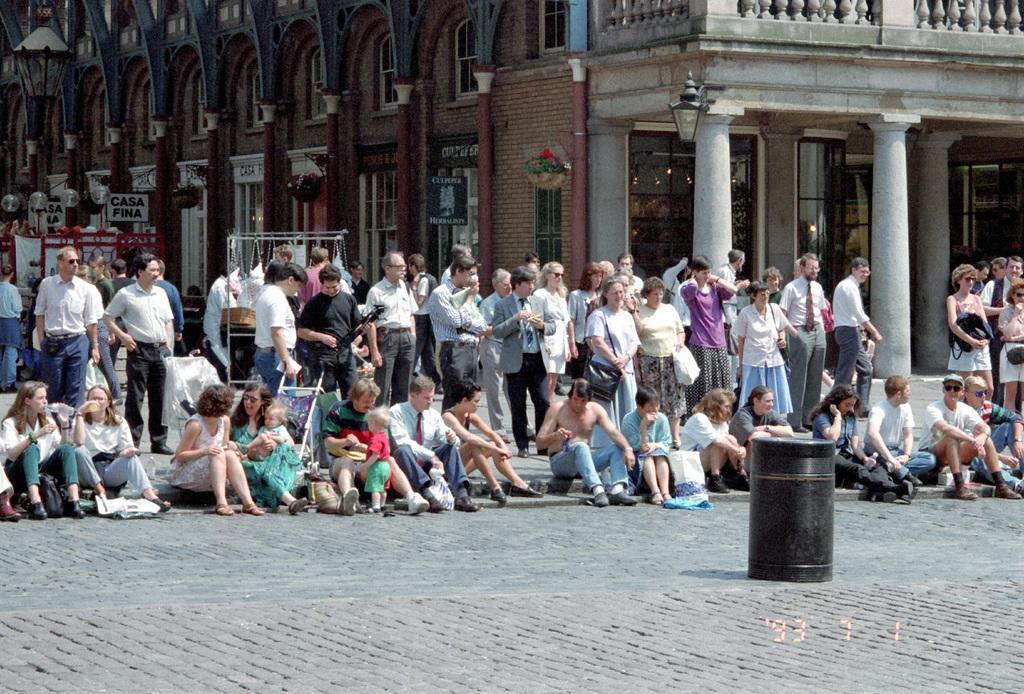Please provide a concise description of this image. Here in this picture in the middle we can see number of people sitting and standing on the ground and in front of them we can see a drum present and behind them we can see a building with number of windows present and we can see some people are wearing goggles and carrying bags with them and we can also see hoardings present on the building and in the front we can see pillars present and we can also see light posts present. 